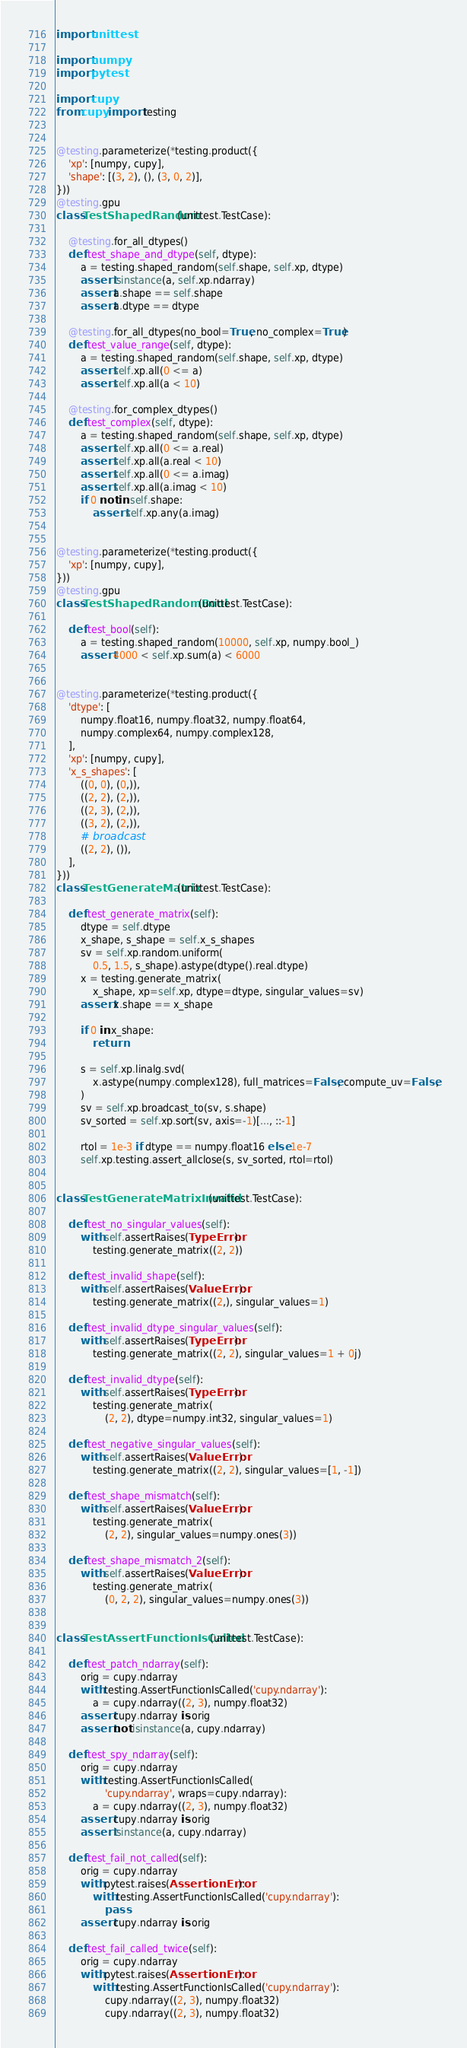<code> <loc_0><loc_0><loc_500><loc_500><_Python_>import unittest

import numpy
import pytest

import cupy
from cupy import testing


@testing.parameterize(*testing.product({
    'xp': [numpy, cupy],
    'shape': [(3, 2), (), (3, 0, 2)],
}))
@testing.gpu
class TestShapedRandom(unittest.TestCase):

    @testing.for_all_dtypes()
    def test_shape_and_dtype(self, dtype):
        a = testing.shaped_random(self.shape, self.xp, dtype)
        assert isinstance(a, self.xp.ndarray)
        assert a.shape == self.shape
        assert a.dtype == dtype

    @testing.for_all_dtypes(no_bool=True, no_complex=True)
    def test_value_range(self, dtype):
        a = testing.shaped_random(self.shape, self.xp, dtype)
        assert self.xp.all(0 <= a)
        assert self.xp.all(a < 10)

    @testing.for_complex_dtypes()
    def test_complex(self, dtype):
        a = testing.shaped_random(self.shape, self.xp, dtype)
        assert self.xp.all(0 <= a.real)
        assert self.xp.all(a.real < 10)
        assert self.xp.all(0 <= a.imag)
        assert self.xp.all(a.imag < 10)
        if 0 not in self.shape:
            assert self.xp.any(a.imag)


@testing.parameterize(*testing.product({
    'xp': [numpy, cupy],
}))
@testing.gpu
class TestShapedRandomBool(unittest.TestCase):

    def test_bool(self):
        a = testing.shaped_random(10000, self.xp, numpy.bool_)
        assert 4000 < self.xp.sum(a) < 6000


@testing.parameterize(*testing.product({
    'dtype': [
        numpy.float16, numpy.float32, numpy.float64,
        numpy.complex64, numpy.complex128,
    ],
    'xp': [numpy, cupy],
    'x_s_shapes': [
        ((0, 0), (0,)),
        ((2, 2), (2,)),
        ((2, 3), (2,)),
        ((3, 2), (2,)),
        # broadcast
        ((2, 2), ()),
    ],
}))
class TestGenerateMatrix(unittest.TestCase):

    def test_generate_matrix(self):
        dtype = self.dtype
        x_shape, s_shape = self.x_s_shapes
        sv = self.xp.random.uniform(
            0.5, 1.5, s_shape).astype(dtype().real.dtype)
        x = testing.generate_matrix(
            x_shape, xp=self.xp, dtype=dtype, singular_values=sv)
        assert x.shape == x_shape

        if 0 in x_shape:
            return

        s = self.xp.linalg.svd(
            x.astype(numpy.complex128), full_matrices=False, compute_uv=False,
        )
        sv = self.xp.broadcast_to(sv, s.shape)
        sv_sorted = self.xp.sort(sv, axis=-1)[..., ::-1]

        rtol = 1e-3 if dtype == numpy.float16 else 1e-7
        self.xp.testing.assert_allclose(s, sv_sorted, rtol=rtol)


class TestGenerateMatrixInvalid(unittest.TestCase):

    def test_no_singular_values(self):
        with self.assertRaises(TypeError):
            testing.generate_matrix((2, 2))

    def test_invalid_shape(self):
        with self.assertRaises(ValueError):
            testing.generate_matrix((2,), singular_values=1)

    def test_invalid_dtype_singular_values(self):
        with self.assertRaises(TypeError):
            testing.generate_matrix((2, 2), singular_values=1 + 0j)

    def test_invalid_dtype(self):
        with self.assertRaises(TypeError):
            testing.generate_matrix(
                (2, 2), dtype=numpy.int32, singular_values=1)

    def test_negative_singular_values(self):
        with self.assertRaises(ValueError):
            testing.generate_matrix((2, 2), singular_values=[1, -1])

    def test_shape_mismatch(self):
        with self.assertRaises(ValueError):
            testing.generate_matrix(
                (2, 2), singular_values=numpy.ones(3))

    def test_shape_mismatch_2(self):
        with self.assertRaises(ValueError):
            testing.generate_matrix(
                (0, 2, 2), singular_values=numpy.ones(3))


class TestAssertFunctionIsCalled(unittest.TestCase):

    def test_patch_ndarray(self):
        orig = cupy.ndarray
        with testing.AssertFunctionIsCalled('cupy.ndarray'):
            a = cupy.ndarray((2, 3), numpy.float32)
        assert cupy.ndarray is orig
        assert not isinstance(a, cupy.ndarray)

    def test_spy_ndarray(self):
        orig = cupy.ndarray
        with testing.AssertFunctionIsCalled(
                'cupy.ndarray', wraps=cupy.ndarray):
            a = cupy.ndarray((2, 3), numpy.float32)
        assert cupy.ndarray is orig
        assert isinstance(a, cupy.ndarray)

    def test_fail_not_called(self):
        orig = cupy.ndarray
        with pytest.raises(AssertionError):
            with testing.AssertFunctionIsCalled('cupy.ndarray'):
                pass
        assert cupy.ndarray is orig

    def test_fail_called_twice(self):
        orig = cupy.ndarray
        with pytest.raises(AssertionError):
            with testing.AssertFunctionIsCalled('cupy.ndarray'):
                cupy.ndarray((2, 3), numpy.float32)
                cupy.ndarray((2, 3), numpy.float32)</code> 